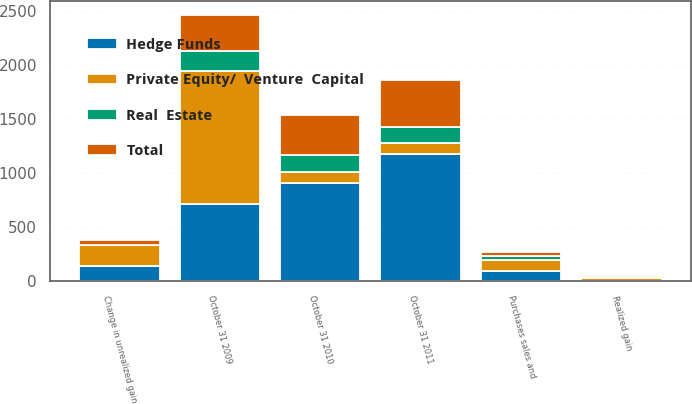Convert chart. <chart><loc_0><loc_0><loc_500><loc_500><stacked_bar_chart><ecel><fcel>October 31 2009<fcel>Realized gain<fcel>Change in unrealized gain<fcel>Purchases sales and<fcel>October 31 2010<fcel>October 31 2011<nl><fcel>Private Equity/  Venture  Capital<fcel>1233<fcel>21<fcel>192<fcel>99<fcel>98<fcel>98<nl><fcel>Total<fcel>336<fcel>16<fcel>48<fcel>39<fcel>378<fcel>437<nl><fcel>Hedge Funds<fcel>716<fcel>4<fcel>141<fcel>95<fcel>912<fcel>1178<nl><fcel>Real  Estate<fcel>181<fcel>1<fcel>3<fcel>35<fcel>153<fcel>150<nl></chart> 